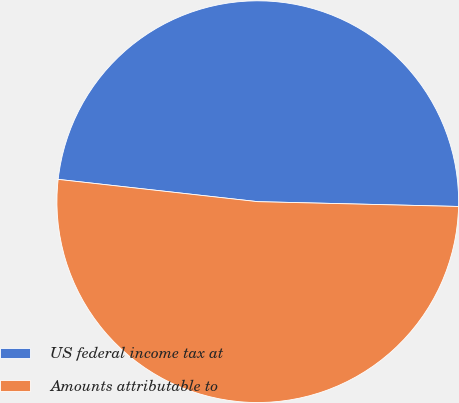Convert chart. <chart><loc_0><loc_0><loc_500><loc_500><pie_chart><fcel>US federal income tax at<fcel>Amounts attributable to<nl><fcel>48.61%<fcel>51.39%<nl></chart> 